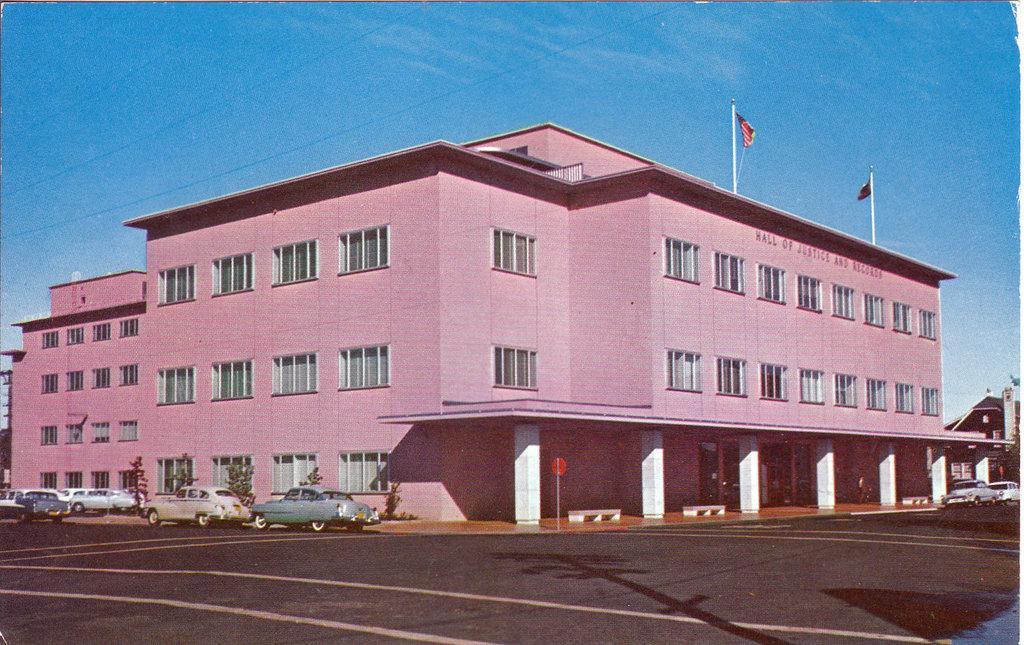Could you give a brief overview of what you see in this image? In this image we can see a building and there are two flags and there are some vehicles on the road. We can see a house on the right side and there are some trees and at the top we can see the sky. 